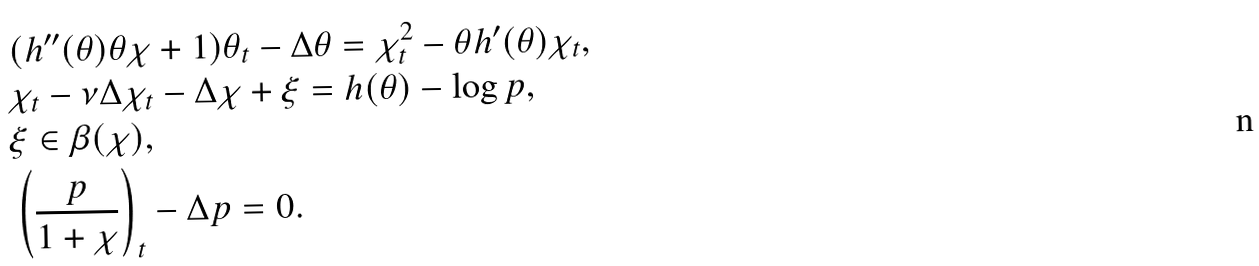Convert formula to latex. <formula><loc_0><loc_0><loc_500><loc_500>& ( h ^ { \prime \prime } ( \theta ) \theta \chi + 1 ) \theta _ { t } - \Delta \theta = \chi _ { t } ^ { 2 } - \theta h ^ { \prime } ( \theta ) \chi _ { t } , \\ & \chi _ { t } - \nu \Delta \chi _ { t } - \Delta \chi + \xi = h ( \theta ) - \log p , \\ & \xi \in \beta ( \chi ) , \\ & \left ( \frac { p } { 1 + \chi } \right ) _ { t } - \Delta p = 0 .</formula> 